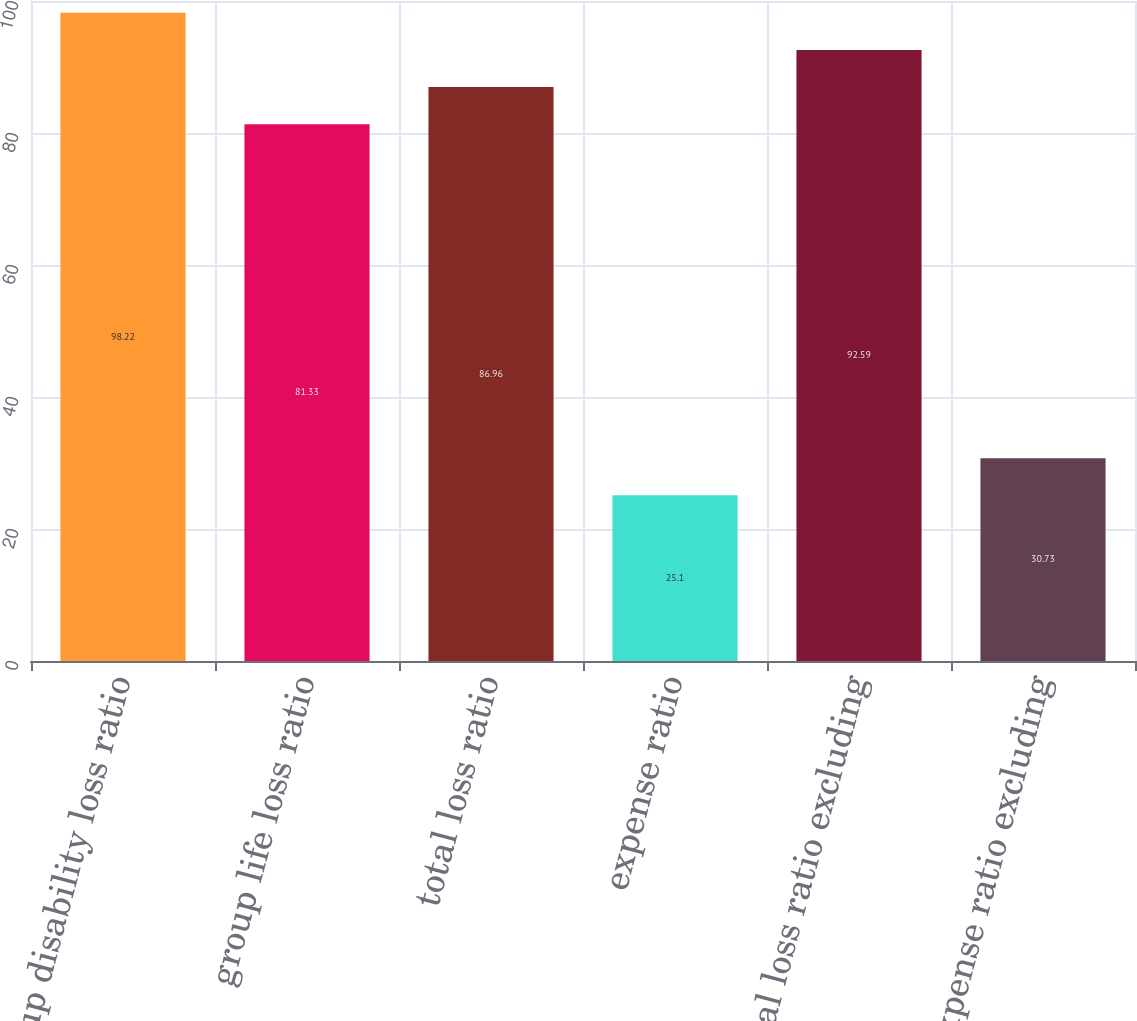Convert chart. <chart><loc_0><loc_0><loc_500><loc_500><bar_chart><fcel>group disability loss ratio<fcel>group life loss ratio<fcel>total loss ratio<fcel>expense ratio<fcel>total loss ratio excluding<fcel>expense ratio excluding<nl><fcel>98.22<fcel>81.33<fcel>86.96<fcel>25.1<fcel>92.59<fcel>30.73<nl></chart> 